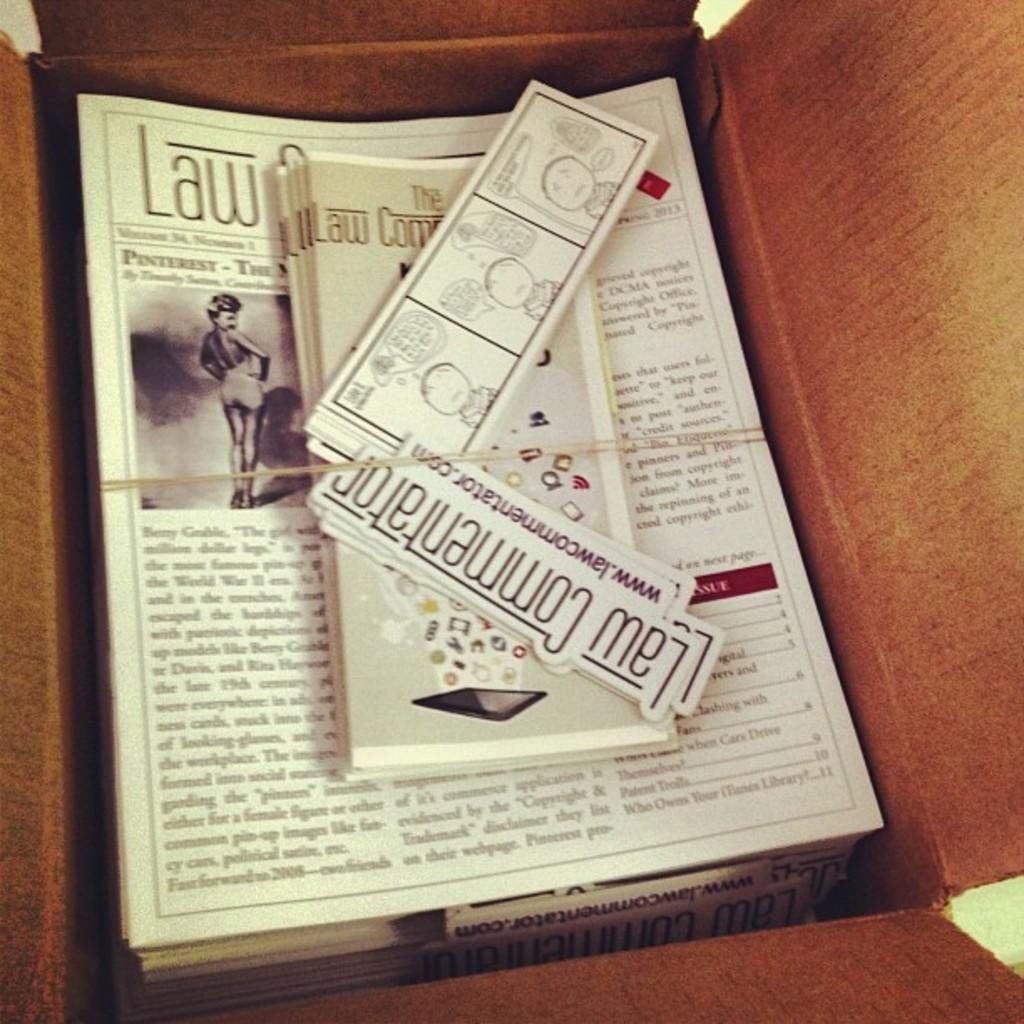What is present on the papers in the image? The papers have text and pictures in the image. How are the papers secured or held together? The papers are tied with a rope. Where are the papers placed or stored? The papers are placed in a cardboard box. What type of honey can be seen dripping from the spot on the papers in the image? There is no honey or spot present on the papers in the image; they only have text and pictures. Can you describe the bird that is perched on the rope in the image? There is no bird present in the image; the papers are tied with a rope, but no bird is visible. 